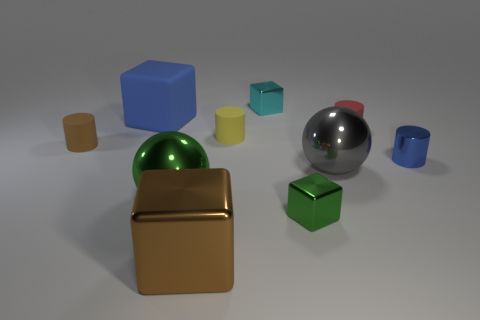Subtract all gray blocks. Subtract all red cylinders. How many blocks are left? 4 Subtract all spheres. How many objects are left? 8 Subtract 0 green cylinders. How many objects are left? 10 Subtract all big purple cubes. Subtract all small matte cylinders. How many objects are left? 7 Add 5 blue objects. How many blue objects are left? 7 Add 9 small cyan shiny cubes. How many small cyan shiny cubes exist? 10 